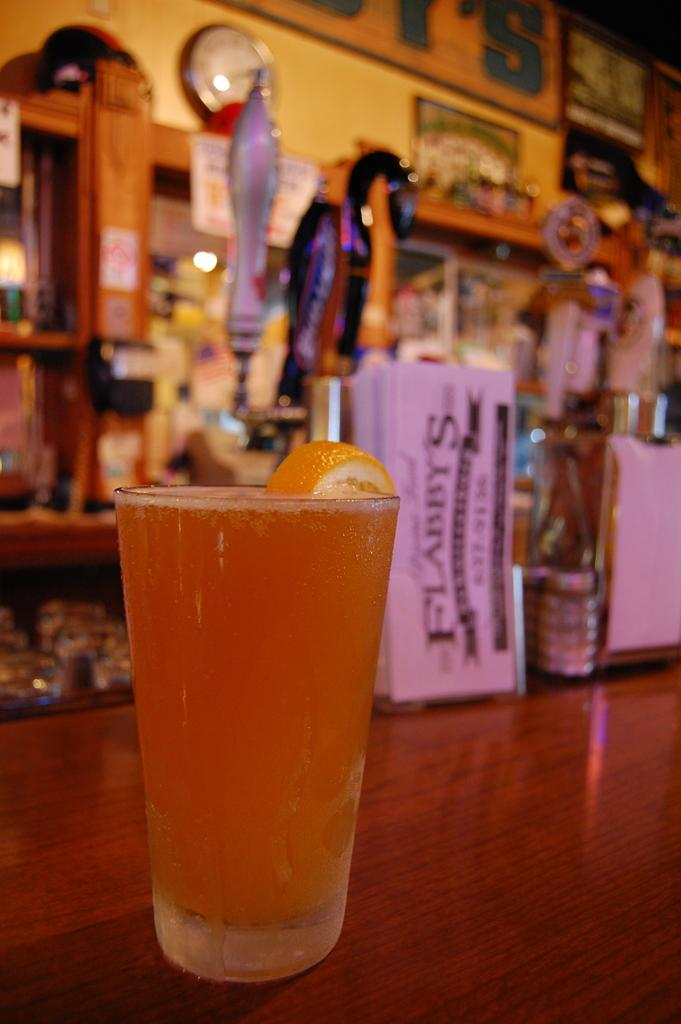Provide a one-sentence caption for the provided image. A glass og light colored beer with a orange in it at Flabbys. 